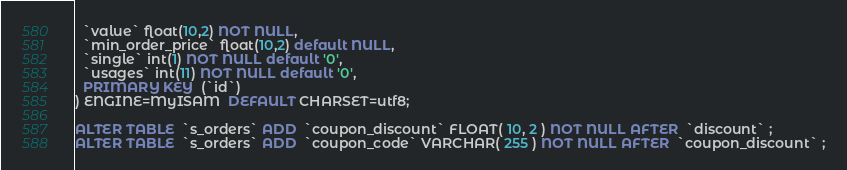<code> <loc_0><loc_0><loc_500><loc_500><_SQL_>  `value` float(10,2) NOT NULL,
  `min_order_price` float(10,2) default NULL,
  `single` int(1) NOT NULL default '0',
  `usages` int(11) NOT NULL default '0',
  PRIMARY KEY  (`id`)
) ENGINE=MyISAM  DEFAULT CHARSET=utf8;

ALTER TABLE  `s_orders` ADD  `coupon_discount` FLOAT( 10, 2 ) NOT NULL AFTER  `discount` ;
ALTER TABLE  `s_orders` ADD  `coupon_code` VARCHAR( 255 ) NOT NULL AFTER  `coupon_discount` ;</code> 